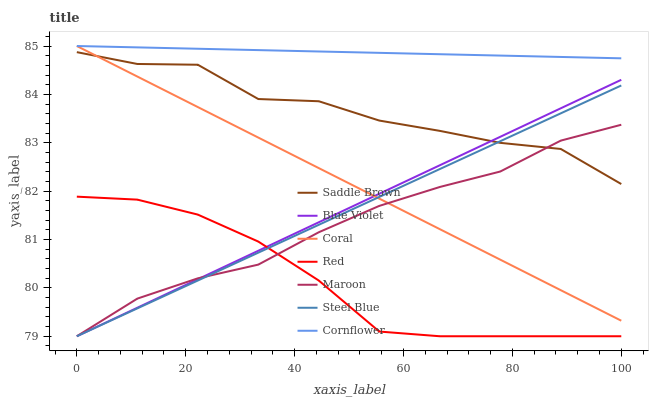Does Red have the minimum area under the curve?
Answer yes or no. Yes. Does Cornflower have the maximum area under the curve?
Answer yes or no. Yes. Does Coral have the minimum area under the curve?
Answer yes or no. No. Does Coral have the maximum area under the curve?
Answer yes or no. No. Is Blue Violet the smoothest?
Answer yes or no. Yes. Is Saddle Brown the roughest?
Answer yes or no. Yes. Is Coral the smoothest?
Answer yes or no. No. Is Coral the roughest?
Answer yes or no. No. Does Steel Blue have the lowest value?
Answer yes or no. Yes. Does Coral have the lowest value?
Answer yes or no. No. Does Coral have the highest value?
Answer yes or no. Yes. Does Steel Blue have the highest value?
Answer yes or no. No. Is Red less than Saddle Brown?
Answer yes or no. Yes. Is Cornflower greater than Saddle Brown?
Answer yes or no. Yes. Does Steel Blue intersect Coral?
Answer yes or no. Yes. Is Steel Blue less than Coral?
Answer yes or no. No. Is Steel Blue greater than Coral?
Answer yes or no. No. Does Red intersect Saddle Brown?
Answer yes or no. No. 